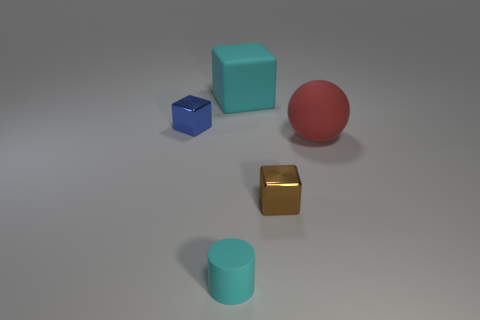There is a tiny metallic cube behind the large rubber object that is in front of the cube to the left of the cyan cylinder; what color is it?
Offer a very short reply. Blue. Is the number of big cyan cubes in front of the large red rubber object less than the number of rubber cubes?
Provide a succinct answer. Yes. Is the shape of the small shiny thing left of the cyan cylinder the same as the rubber thing that is on the right side of the large cyan matte object?
Provide a succinct answer. No. What number of things are either shiny blocks that are to the right of the tiny blue thing or large matte objects?
Your answer should be very brief. 3. There is a cube that is the same color as the rubber cylinder; what is its material?
Ensure brevity in your answer.  Rubber. Are there any blue blocks right of the cyan object that is in front of the small thing that is on the left side of the small matte cylinder?
Your answer should be very brief. No. Are there fewer brown metal blocks behind the matte cylinder than metal cubes that are to the left of the cyan cube?
Your answer should be compact. No. What is the color of the cylinder that is the same material as the big cube?
Offer a terse response. Cyan. What is the color of the cube that is to the left of the rubber object that is behind the small blue cube?
Make the answer very short. Blue. Are there any other cubes of the same color as the large block?
Give a very brief answer. No. 